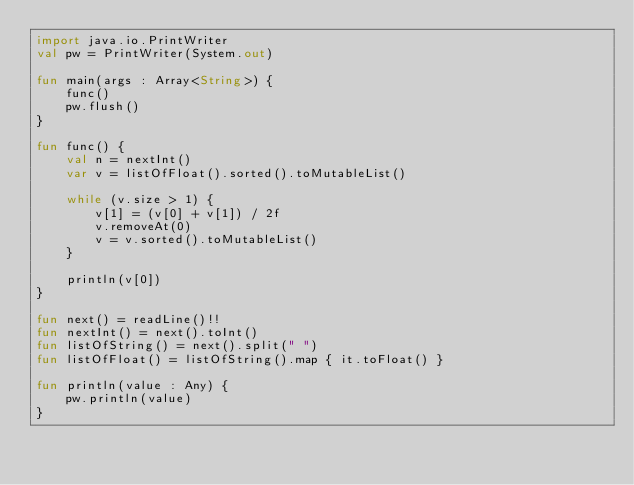<code> <loc_0><loc_0><loc_500><loc_500><_Kotlin_>import java.io.PrintWriter
val pw = PrintWriter(System.out)

fun main(args : Array<String>) {
    func()
    pw.flush()
}

fun func() {
    val n = nextInt()
    var v = listOfFloat().sorted().toMutableList()

    while (v.size > 1) {
        v[1] = (v[0] + v[1]) / 2f
        v.removeAt(0)
        v = v.sorted().toMutableList()
    }

    println(v[0])
}

fun next() = readLine()!!
fun nextInt() = next().toInt()
fun listOfString() = next().split(" ")
fun listOfFloat() = listOfString().map { it.toFloat() }

fun println(value : Any) {
    pw.println(value)
}</code> 